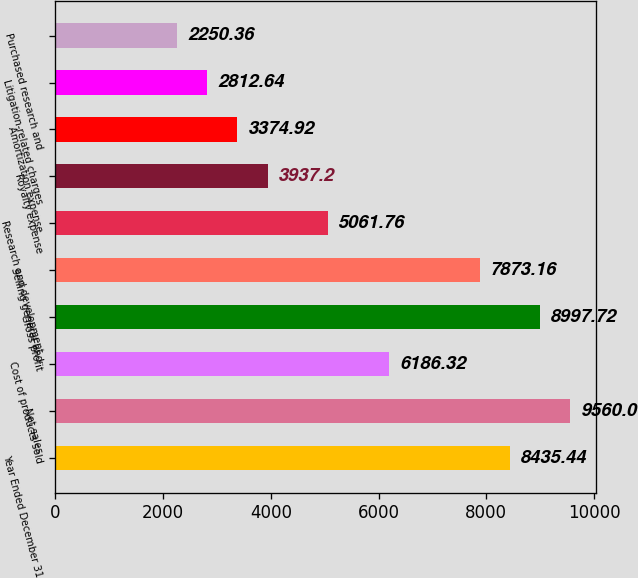<chart> <loc_0><loc_0><loc_500><loc_500><bar_chart><fcel>Year Ended December 31<fcel>Net sales<fcel>Cost of products sold<fcel>Gross profit<fcel>Selling general and<fcel>Research and development<fcel>Royalty expense<fcel>Amortization expense<fcel>Litigation-related charges<fcel>Purchased research and<nl><fcel>8435.44<fcel>9560<fcel>6186.32<fcel>8997.72<fcel>7873.16<fcel>5061.76<fcel>3937.2<fcel>3374.92<fcel>2812.64<fcel>2250.36<nl></chart> 